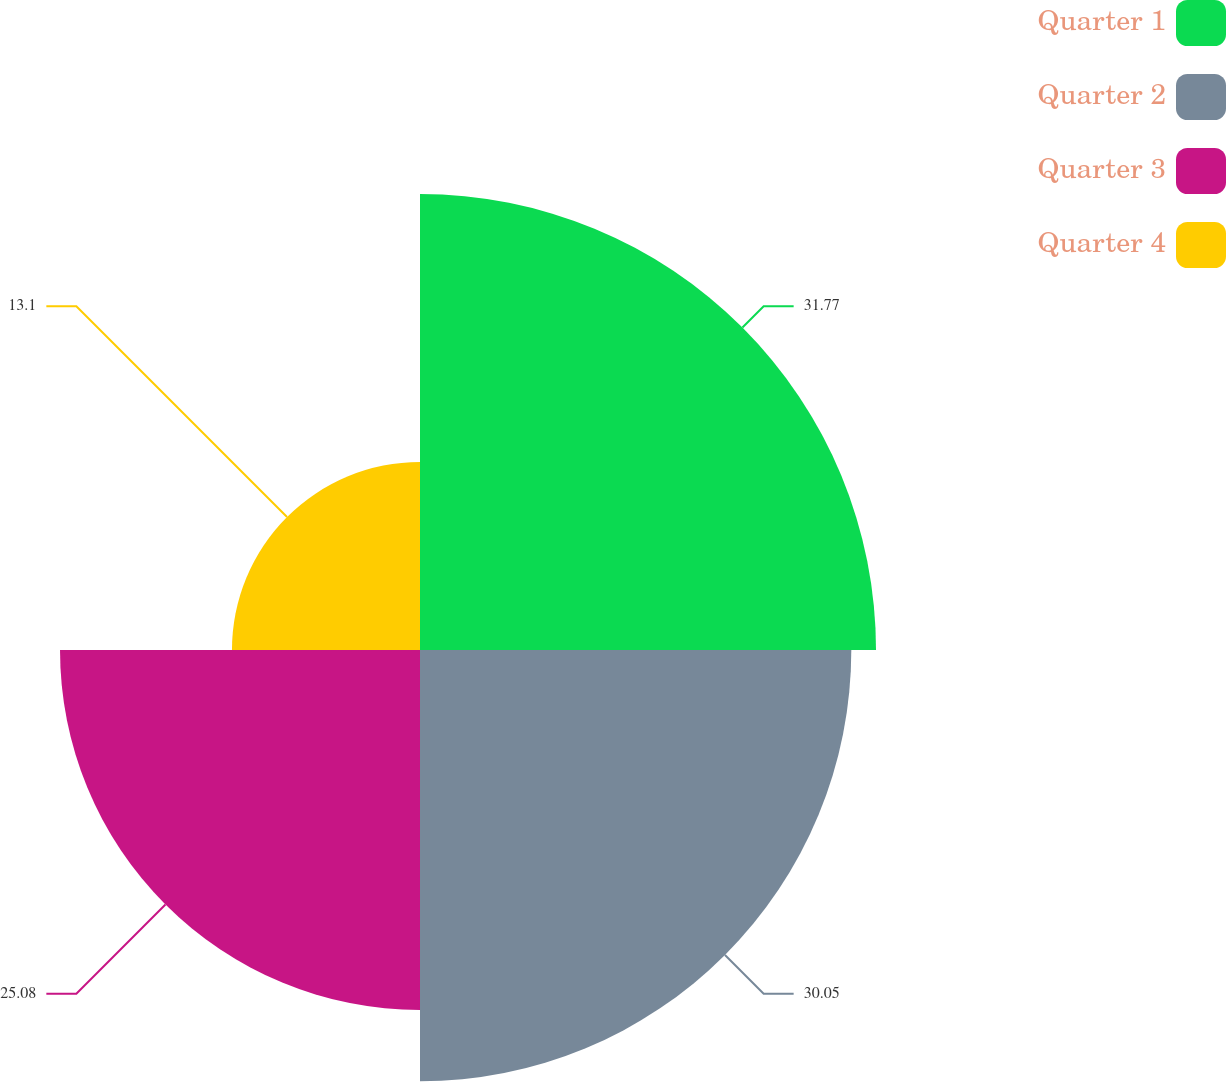<chart> <loc_0><loc_0><loc_500><loc_500><pie_chart><fcel>Quarter 1<fcel>Quarter 2<fcel>Quarter 3<fcel>Quarter 4<nl><fcel>31.77%<fcel>30.05%<fcel>25.08%<fcel>13.1%<nl></chart> 